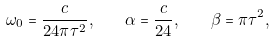Convert formula to latex. <formula><loc_0><loc_0><loc_500><loc_500>\omega _ { 0 } = \frac { c } { 2 4 \pi \tau ^ { 2 } } , \quad \alpha = \frac { c } { 2 4 } , \quad \beta = \pi \tau ^ { 2 } ,</formula> 